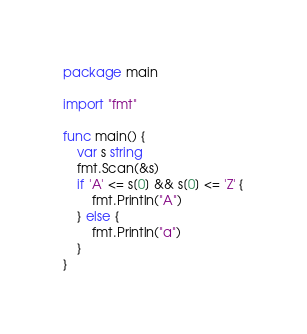Convert code to text. <code><loc_0><loc_0><loc_500><loc_500><_Go_>package main

import "fmt"

func main() {
	var s string
	fmt.Scan(&s)
	if 'A' <= s[0] && s[0] <= 'Z' {
		fmt.Println("A")
	} else {
		fmt.Println("a")
	}
}
</code> 